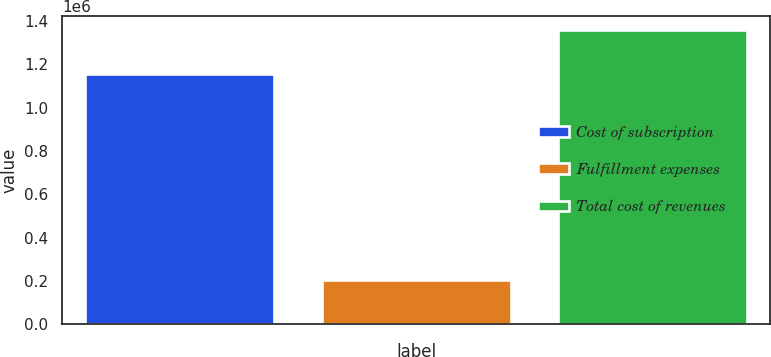<chart> <loc_0><loc_0><loc_500><loc_500><bar_chart><fcel>Cost of subscription<fcel>Fulfillment expenses<fcel>Total cost of revenues<nl><fcel>1.15411e+06<fcel>203246<fcel>1.35736e+06<nl></chart> 